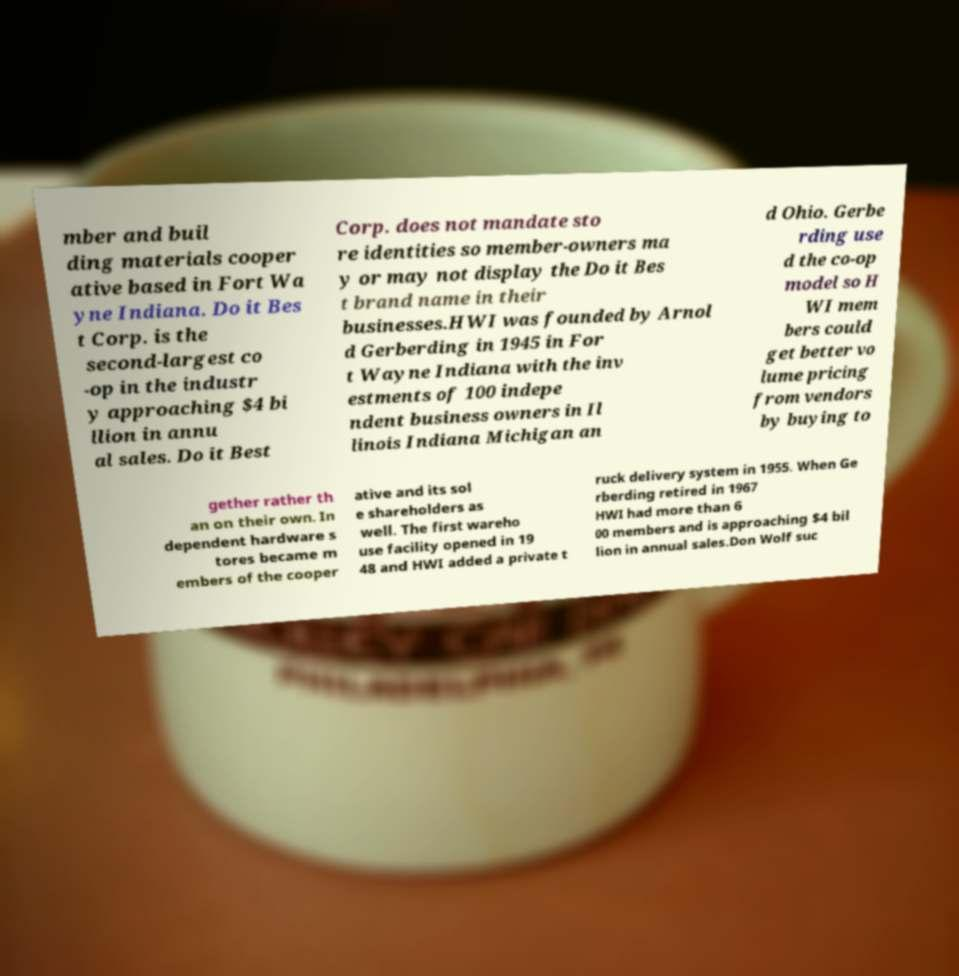Could you assist in decoding the text presented in this image and type it out clearly? mber and buil ding materials cooper ative based in Fort Wa yne Indiana. Do it Bes t Corp. is the second-largest co -op in the industr y approaching $4 bi llion in annu al sales. Do it Best Corp. does not mandate sto re identities so member-owners ma y or may not display the Do it Bes t brand name in their businesses.HWI was founded by Arnol d Gerberding in 1945 in For t Wayne Indiana with the inv estments of 100 indepe ndent business owners in Il linois Indiana Michigan an d Ohio. Gerbe rding use d the co-op model so H WI mem bers could get better vo lume pricing from vendors by buying to gether rather th an on their own. In dependent hardware s tores became m embers of the cooper ative and its sol e shareholders as well. The first wareho use facility opened in 19 48 and HWI added a private t ruck delivery system in 1955. When Ge rberding retired in 1967 HWI had more than 6 00 members and is approaching $4 bil lion in annual sales.Don Wolf suc 